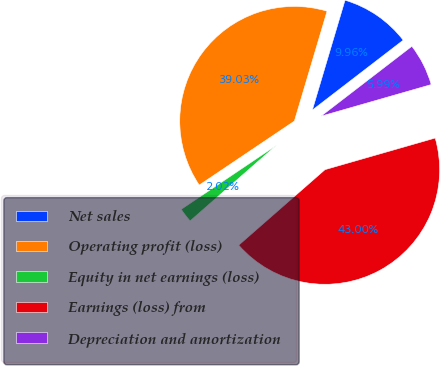Convert chart to OTSL. <chart><loc_0><loc_0><loc_500><loc_500><pie_chart><fcel>Net sales<fcel>Operating profit (loss)<fcel>Equity in net earnings (loss)<fcel>Earnings (loss) from<fcel>Depreciation and amortization<nl><fcel>9.96%<fcel>39.03%<fcel>2.02%<fcel>43.0%<fcel>5.99%<nl></chart> 